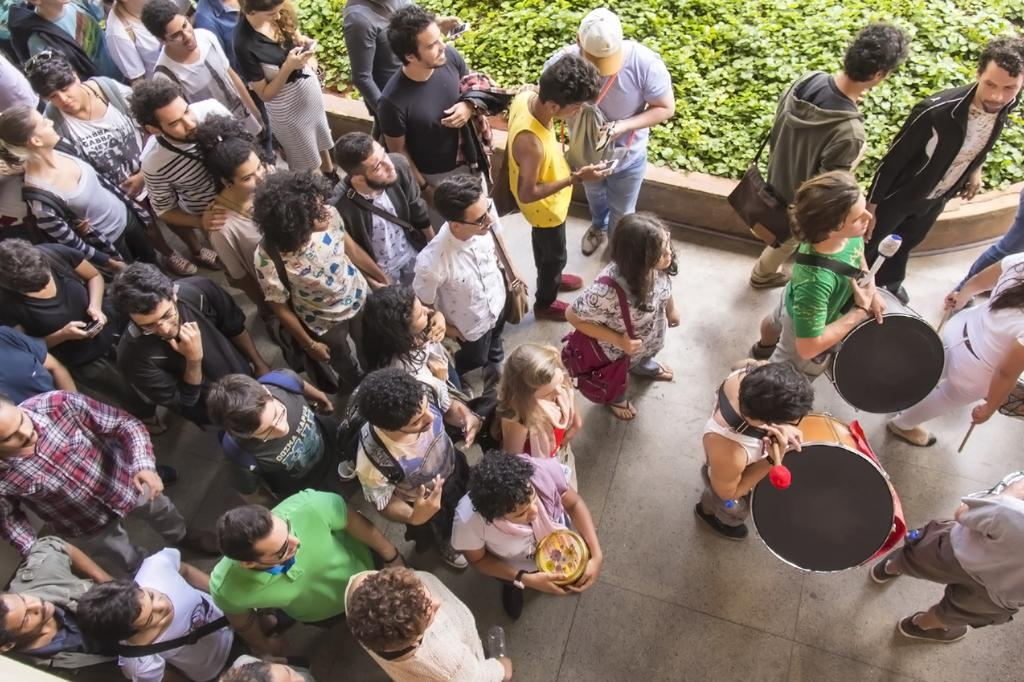How many people are visible in the image? There are many people standing in the image. What are the two men holding in their hands? The two men are holding sticks in their hands. What are the sticks used for? The sticks are used to play the drums, as the men are holding drums as well. What can be seen in the background of the image? There is a small wall and small plants in the background of the image. What type of crime is being committed in the image? There is no crime being committed in the image; it shows people and musicians with drums. How much debt is visible in the image? There is no debt visible in the image; it is focused on people and musicians with drums. 